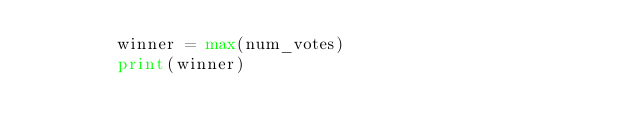<code> <loc_0><loc_0><loc_500><loc_500><_Python_>        winner = max(num_votes)
        print(winner)



    



    
    


</code> 